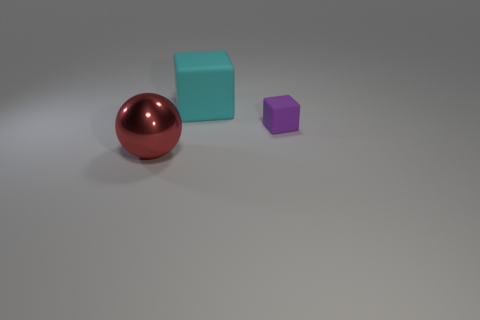Add 1 metallic things. How many objects exist? 4 Subtract all cubes. How many objects are left? 1 Add 3 large red spheres. How many large red spheres are left? 4 Add 3 big gray rubber balls. How many big gray rubber balls exist? 3 Subtract 0 red cylinders. How many objects are left? 3 Subtract all big red spheres. Subtract all metallic balls. How many objects are left? 1 